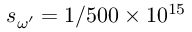<formula> <loc_0><loc_0><loc_500><loc_500>s _ { \omega ^ { \prime } } = 1 / 5 0 0 \times 1 0 ^ { 1 5 }</formula> 